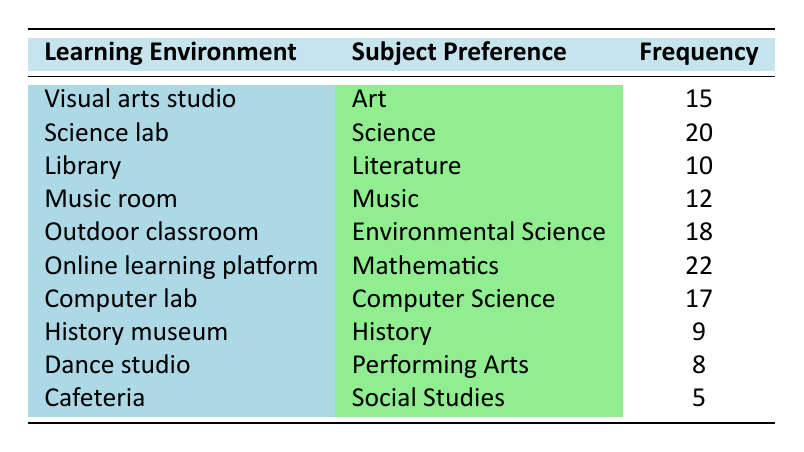What is the frequency of gifted children who prefer Mathematics in the online learning platform? The table indicates that the frequency for Mathematics in the online learning platform is listed directly under that category. Referring to the row for "Online learning platform" and "Mathematics," we find the frequency of 22.
Answer: 22 Which learning environment shows the highest frequency preference for gifted children? By examining the frequency values for all learning environments listed in the table, we identify the maximum frequency. The highest frequency is found under "Online learning platform" with a frequency of 22.
Answer: Online learning platform What is the total frequency of gifted children who prefer subjects related to arts? To find this, we need to sum the frequencies of all rows where the subject preference is related to arts: "Visual arts studio" (15), "Music room" (12), and "Dance studio" (8). So, we calculate 15 + 12 + 8 = 35.
Answer: 35 Is the frequency of gifted children who prefer Environmental Science greater than those who prefer Literature? The frequency for Environmental Science is 18 (from "Outdoor classroom") and for Literature is 10 (from "Library"). Since 18 is greater than 10, the statement is true.
Answer: Yes What is the average frequency of gifted children's subject preferences across all learning environments? To find the average frequency, we need to add up all the frequencies: 15 + 20 + 10 + 12 + 18 + 22 + 17 + 9 + 8 + 5 = 126. Then, we divide the total by the number of categories (10), giving us an average of 126 / 10 = 12.6.
Answer: 12.6 Which subjects have a frequency lower than 10? Looking through the table, we can identify the frequencies: "History" has 9, and "Social Studies" has 5, both of which are lower than 10.
Answer: History, Social Studies What is the difference in frequency between the subject preference for Science and Computer Science? The frequency for Science (from "Science lab") is 20, and for Computer Science (from "Computer lab") is 17. To find the difference, we calculate 20 - 17 = 3.
Answer: 3 How many more gifted children prefer Science compared to Arts? The frequency for Science is 20 and for Arts is 15. By calculating the difference, we find 20 - 15 = 5.
Answer: 5 Is there a preferred learning environment for Music that has a frequency greater than 10? The frequency of "Music room" is 12, which is greater than 10. Thus, the statement is true.
Answer: Yes 